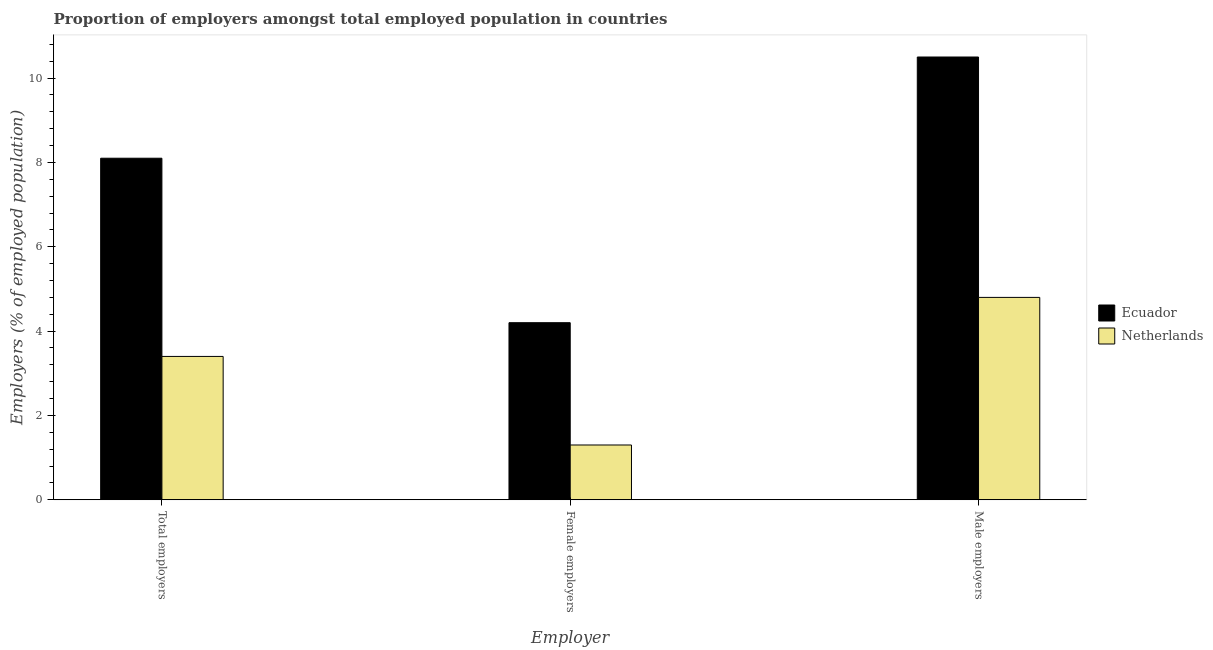How many groups of bars are there?
Your response must be concise. 3. Are the number of bars on each tick of the X-axis equal?
Your answer should be very brief. Yes. How many bars are there on the 3rd tick from the left?
Your answer should be compact. 2. How many bars are there on the 2nd tick from the right?
Provide a succinct answer. 2. What is the label of the 1st group of bars from the left?
Your answer should be very brief. Total employers. What is the percentage of female employers in Netherlands?
Ensure brevity in your answer.  1.3. Across all countries, what is the minimum percentage of total employers?
Offer a very short reply. 3.4. In which country was the percentage of total employers maximum?
Your answer should be compact. Ecuador. In which country was the percentage of male employers minimum?
Keep it short and to the point. Netherlands. What is the total percentage of total employers in the graph?
Your answer should be compact. 11.5. What is the difference between the percentage of total employers in Ecuador and that in Netherlands?
Provide a succinct answer. 4.7. What is the difference between the percentage of female employers in Ecuador and the percentage of total employers in Netherlands?
Make the answer very short. 0.8. What is the average percentage of male employers per country?
Your answer should be compact. 7.65. What is the difference between the percentage of total employers and percentage of female employers in Ecuador?
Keep it short and to the point. 3.9. In how many countries, is the percentage of female employers greater than 6.4 %?
Offer a very short reply. 0. What is the ratio of the percentage of male employers in Netherlands to that in Ecuador?
Your response must be concise. 0.46. Is the percentage of female employers in Ecuador less than that in Netherlands?
Your response must be concise. No. Is the difference between the percentage of total employers in Ecuador and Netherlands greater than the difference between the percentage of female employers in Ecuador and Netherlands?
Provide a short and direct response. Yes. What is the difference between the highest and the second highest percentage of female employers?
Ensure brevity in your answer.  2.9. What is the difference between the highest and the lowest percentage of male employers?
Your answer should be very brief. 5.7. Is the sum of the percentage of total employers in Netherlands and Ecuador greater than the maximum percentage of female employers across all countries?
Provide a short and direct response. Yes. What does the 2nd bar from the right in Total employers represents?
Give a very brief answer. Ecuador. Is it the case that in every country, the sum of the percentage of total employers and percentage of female employers is greater than the percentage of male employers?
Offer a terse response. No. How many bars are there?
Offer a terse response. 6. What is the difference between two consecutive major ticks on the Y-axis?
Provide a short and direct response. 2. Does the graph contain any zero values?
Keep it short and to the point. No. Where does the legend appear in the graph?
Your answer should be compact. Center right. How many legend labels are there?
Your response must be concise. 2. How are the legend labels stacked?
Your answer should be compact. Vertical. What is the title of the graph?
Provide a succinct answer. Proportion of employers amongst total employed population in countries. Does "Cabo Verde" appear as one of the legend labels in the graph?
Your answer should be compact. No. What is the label or title of the X-axis?
Keep it short and to the point. Employer. What is the label or title of the Y-axis?
Ensure brevity in your answer.  Employers (% of employed population). What is the Employers (% of employed population) in Ecuador in Total employers?
Make the answer very short. 8.1. What is the Employers (% of employed population) in Netherlands in Total employers?
Your response must be concise. 3.4. What is the Employers (% of employed population) of Ecuador in Female employers?
Provide a short and direct response. 4.2. What is the Employers (% of employed population) of Netherlands in Female employers?
Provide a succinct answer. 1.3. What is the Employers (% of employed population) of Ecuador in Male employers?
Offer a very short reply. 10.5. What is the Employers (% of employed population) of Netherlands in Male employers?
Your answer should be very brief. 4.8. Across all Employer, what is the maximum Employers (% of employed population) of Ecuador?
Give a very brief answer. 10.5. Across all Employer, what is the maximum Employers (% of employed population) in Netherlands?
Provide a short and direct response. 4.8. Across all Employer, what is the minimum Employers (% of employed population) in Ecuador?
Provide a succinct answer. 4.2. Across all Employer, what is the minimum Employers (% of employed population) of Netherlands?
Provide a short and direct response. 1.3. What is the total Employers (% of employed population) of Ecuador in the graph?
Keep it short and to the point. 22.8. What is the difference between the Employers (% of employed population) of Netherlands in Female employers and that in Male employers?
Provide a succinct answer. -3.5. What is the difference between the Employers (% of employed population) in Ecuador in Total employers and the Employers (% of employed population) in Netherlands in Female employers?
Provide a short and direct response. 6.8. What is the difference between the Employers (% of employed population) of Ecuador in Total employers and the Employers (% of employed population) of Netherlands in Male employers?
Your response must be concise. 3.3. What is the difference between the Employers (% of employed population) of Ecuador in Female employers and the Employers (% of employed population) of Netherlands in Male employers?
Your response must be concise. -0.6. What is the average Employers (% of employed population) of Ecuador per Employer?
Offer a very short reply. 7.6. What is the average Employers (% of employed population) of Netherlands per Employer?
Ensure brevity in your answer.  3.17. What is the difference between the Employers (% of employed population) of Ecuador and Employers (% of employed population) of Netherlands in Total employers?
Keep it short and to the point. 4.7. What is the difference between the Employers (% of employed population) in Ecuador and Employers (% of employed population) in Netherlands in Male employers?
Keep it short and to the point. 5.7. What is the ratio of the Employers (% of employed population) of Ecuador in Total employers to that in Female employers?
Offer a terse response. 1.93. What is the ratio of the Employers (% of employed population) of Netherlands in Total employers to that in Female employers?
Provide a short and direct response. 2.62. What is the ratio of the Employers (% of employed population) in Ecuador in Total employers to that in Male employers?
Make the answer very short. 0.77. What is the ratio of the Employers (% of employed population) of Netherlands in Total employers to that in Male employers?
Provide a succinct answer. 0.71. What is the ratio of the Employers (% of employed population) in Ecuador in Female employers to that in Male employers?
Give a very brief answer. 0.4. What is the ratio of the Employers (% of employed population) in Netherlands in Female employers to that in Male employers?
Offer a very short reply. 0.27. What is the difference between the highest and the second highest Employers (% of employed population) in Netherlands?
Ensure brevity in your answer.  1.4. What is the difference between the highest and the lowest Employers (% of employed population) in Ecuador?
Provide a succinct answer. 6.3. 